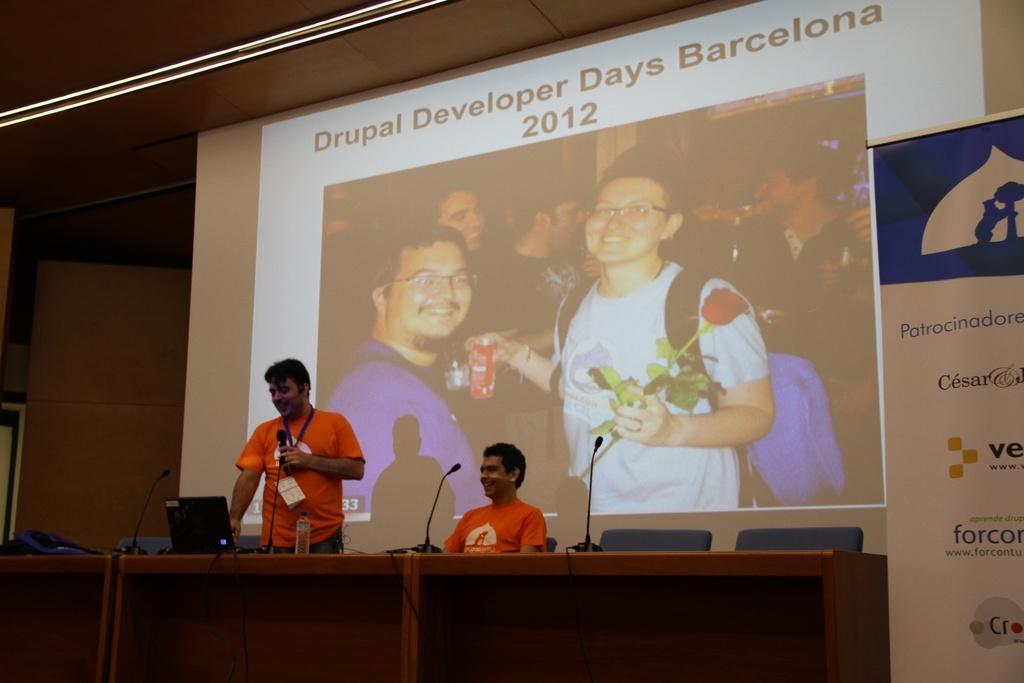Please provide a concise description of this image. In this picture we can see two men where one is sitting on chair and other is holding mic in his hand and standing and they are smiling and in front of them on table we have bottle, laptops, mics and in background we can see screen, banner, wall. 